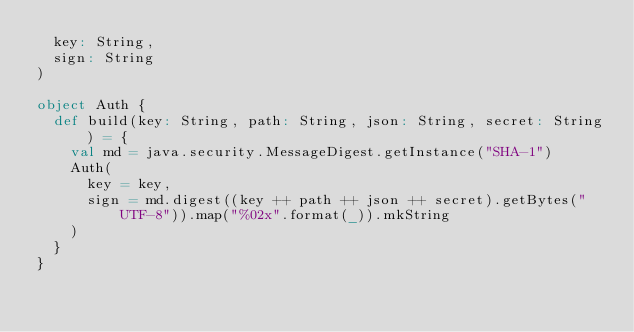Convert code to text. <code><loc_0><loc_0><loc_500><loc_500><_Scala_>  key: String,
  sign: String
)

object Auth {
  def build(key: String, path: String, json: String, secret: String) = {
    val md = java.security.MessageDigest.getInstance("SHA-1")
    Auth(
      key = key,
      sign = md.digest((key ++ path ++ json ++ secret).getBytes("UTF-8")).map("%02x".format(_)).mkString
    )
  }
}
</code> 